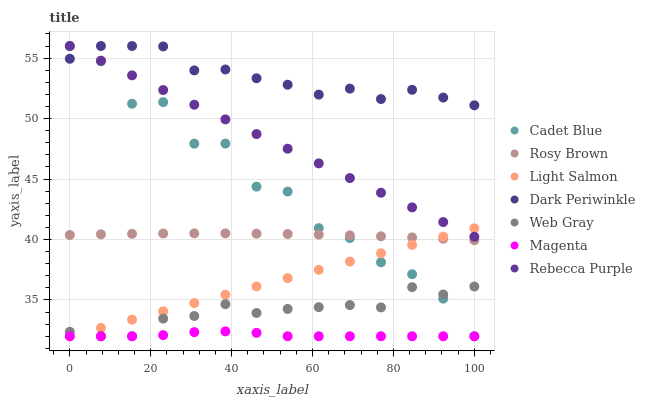Does Magenta have the minimum area under the curve?
Answer yes or no. Yes. Does Dark Periwinkle have the maximum area under the curve?
Answer yes or no. Yes. Does Cadet Blue have the minimum area under the curve?
Answer yes or no. No. Does Cadet Blue have the maximum area under the curve?
Answer yes or no. No. Is Rebecca Purple the smoothest?
Answer yes or no. Yes. Is Cadet Blue the roughest?
Answer yes or no. Yes. Is Rosy Brown the smoothest?
Answer yes or no. No. Is Rosy Brown the roughest?
Answer yes or no. No. Does Light Salmon have the lowest value?
Answer yes or no. Yes. Does Rosy Brown have the lowest value?
Answer yes or no. No. Does Dark Periwinkle have the highest value?
Answer yes or no. Yes. Does Rosy Brown have the highest value?
Answer yes or no. No. Is Rosy Brown less than Dark Periwinkle?
Answer yes or no. Yes. Is Rosy Brown greater than Web Gray?
Answer yes or no. Yes. Does Web Gray intersect Light Salmon?
Answer yes or no. Yes. Is Web Gray less than Light Salmon?
Answer yes or no. No. Is Web Gray greater than Light Salmon?
Answer yes or no. No. Does Rosy Brown intersect Dark Periwinkle?
Answer yes or no. No. 